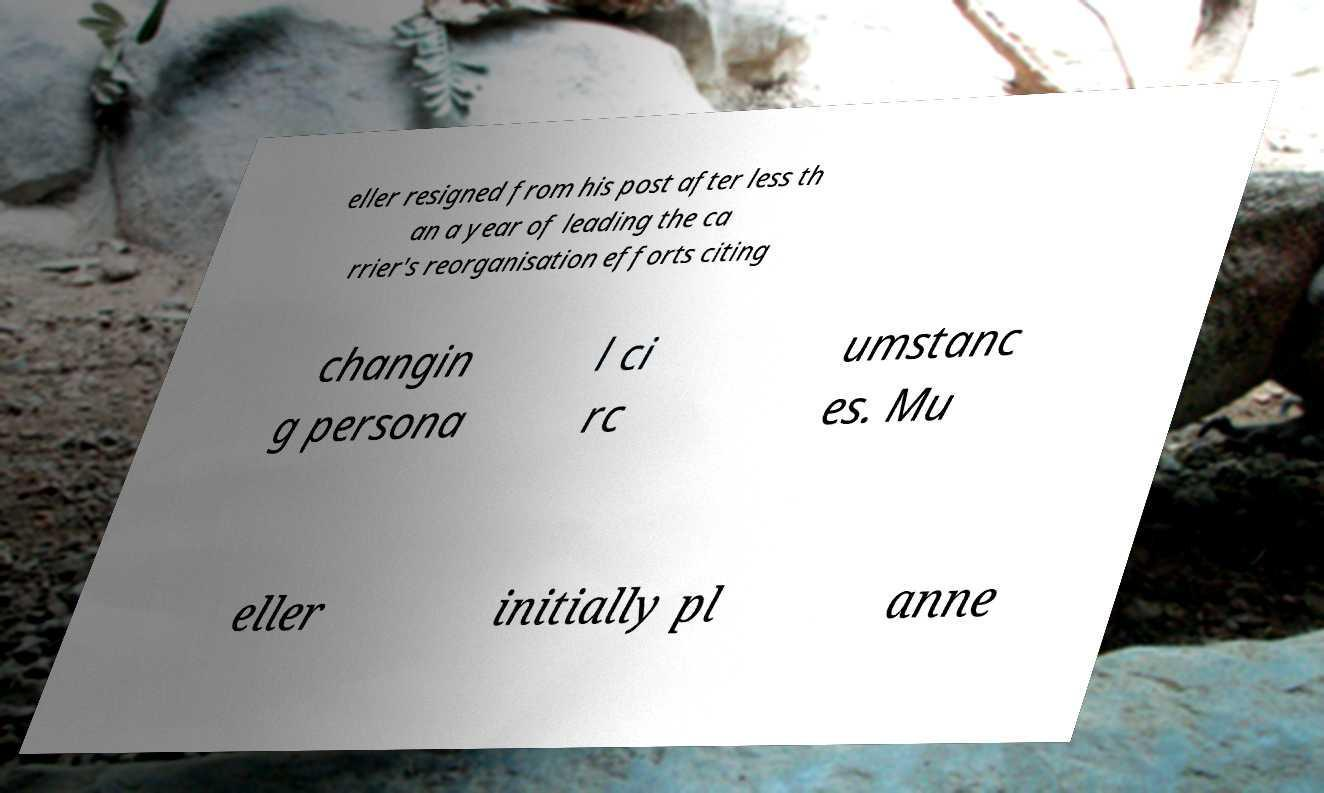For documentation purposes, I need the text within this image transcribed. Could you provide that? eller resigned from his post after less th an a year of leading the ca rrier's reorganisation efforts citing changin g persona l ci rc umstanc es. Mu eller initially pl anne 